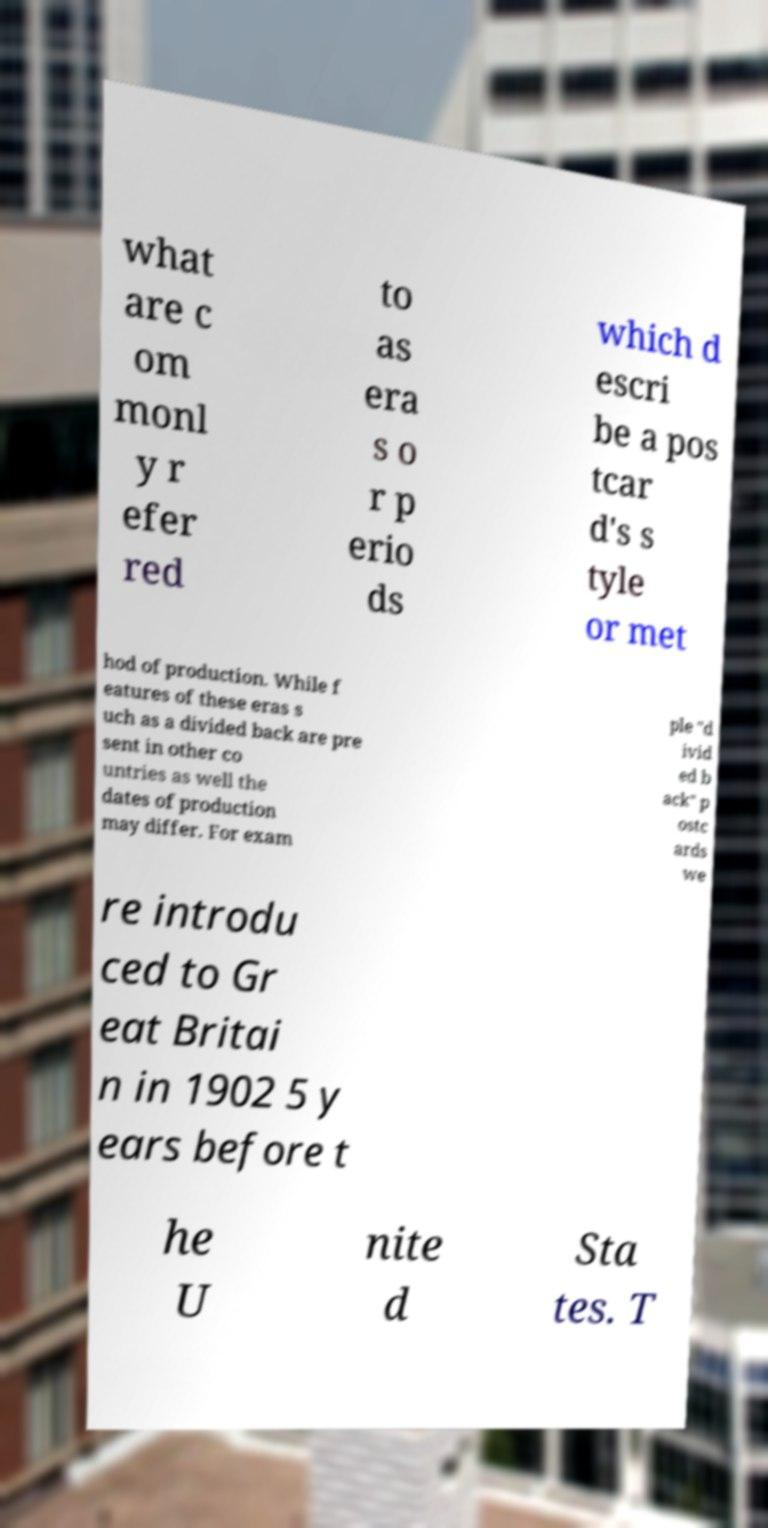Can you read and provide the text displayed in the image?This photo seems to have some interesting text. Can you extract and type it out for me? what are c om monl y r efer red to as era s o r p erio ds which d escri be a pos tcar d's s tyle or met hod of production. While f eatures of these eras s uch as a divided back are pre sent in other co untries as well the dates of production may differ. For exam ple "d ivid ed b ack" p ostc ards we re introdu ced to Gr eat Britai n in 1902 5 y ears before t he U nite d Sta tes. T 